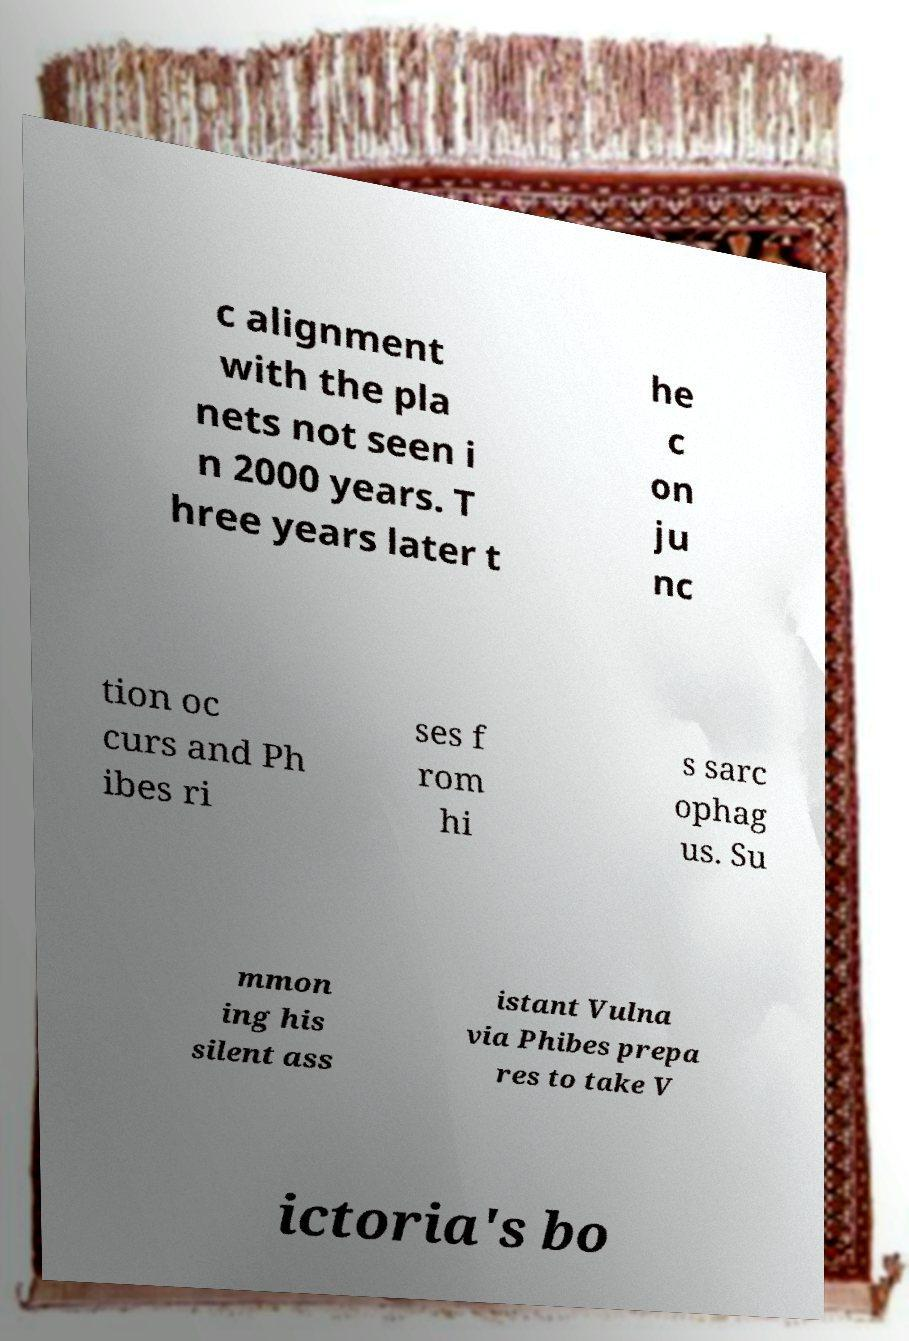I need the written content from this picture converted into text. Can you do that? c alignment with the pla nets not seen i n 2000 years. T hree years later t he c on ju nc tion oc curs and Ph ibes ri ses f rom hi s sarc ophag us. Su mmon ing his silent ass istant Vulna via Phibes prepa res to take V ictoria's bo 